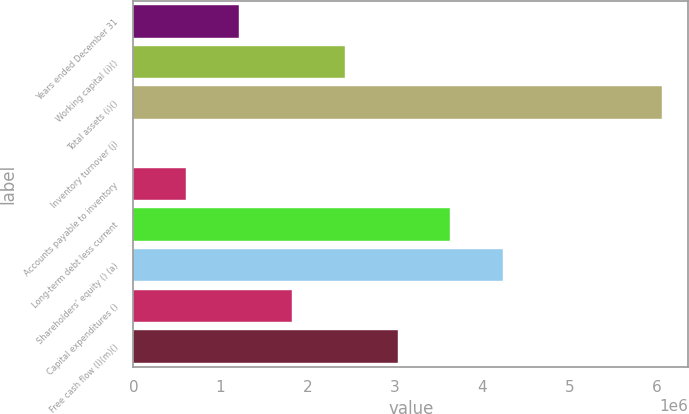Convert chart. <chart><loc_0><loc_0><loc_500><loc_500><bar_chart><fcel>Years ended December 31<fcel>Working capital (i)()<fcel>Total assets (i)()<fcel>Inventory turnover (j)<fcel>Accounts payable to inventory<fcel>Long-term debt less current<fcel>Shareholders' equity () (a)<fcel>Capital expenditures ()<fcel>Free cash flow (l)(m)()<nl><fcel>1.21158e+06<fcel>2.42316e+06<fcel>6.0579e+06<fcel>1.4<fcel>605791<fcel>3.63474e+06<fcel>4.24053e+06<fcel>1.81737e+06<fcel>3.02895e+06<nl></chart> 